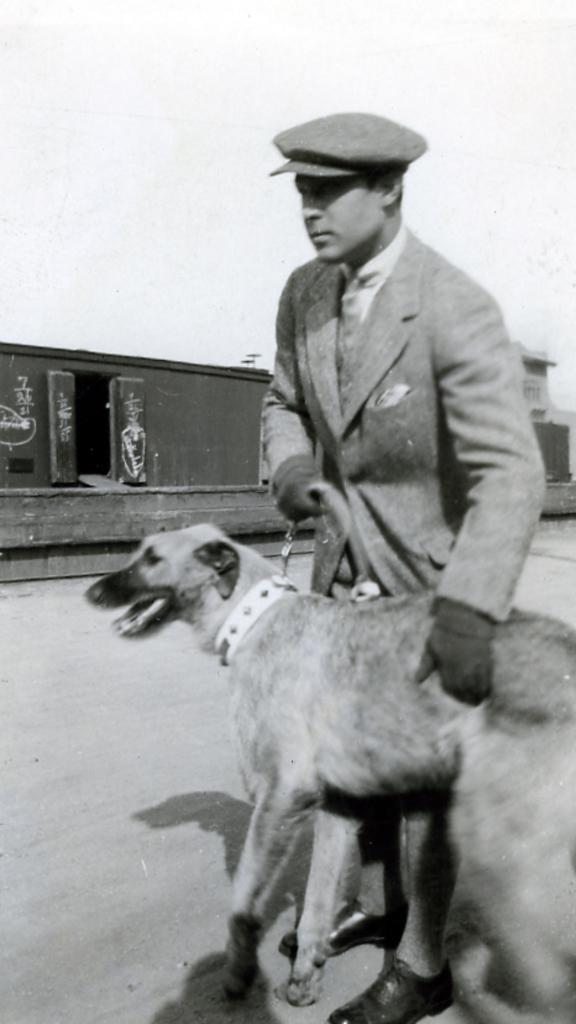What is the color scheme of the image? The image is black and white. Can you describe the person in the image? The person in the image is wearing a suit and a cap. What is the person doing in the image? The person is holding a dog with his hand. What can be seen in the background of the image? There is a road visible in the image. Where is the shelf located in the image? There is no shelf present in the image. What type of alarm is the person holding in the image? There is no alarm present in the image; the person is holding a dog. 